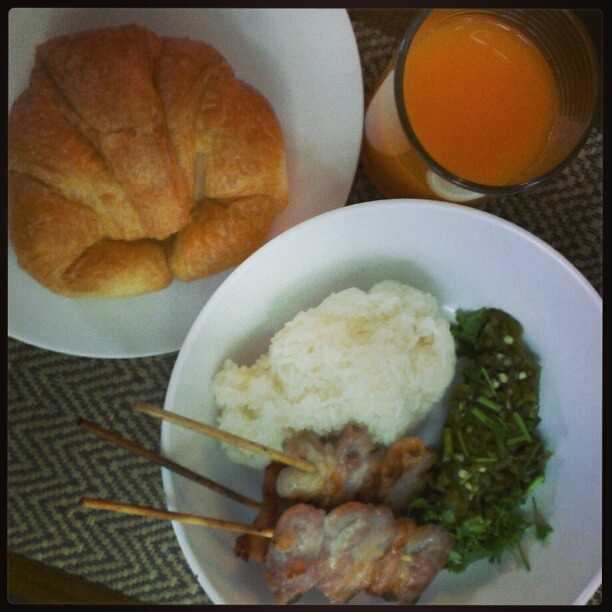Describe the objects in this image and their specific colors. I can see bowl in black, darkgray, and gray tones, cup in black, brown, and maroon tones, and broccoli in black, darkgreen, and teal tones in this image. 